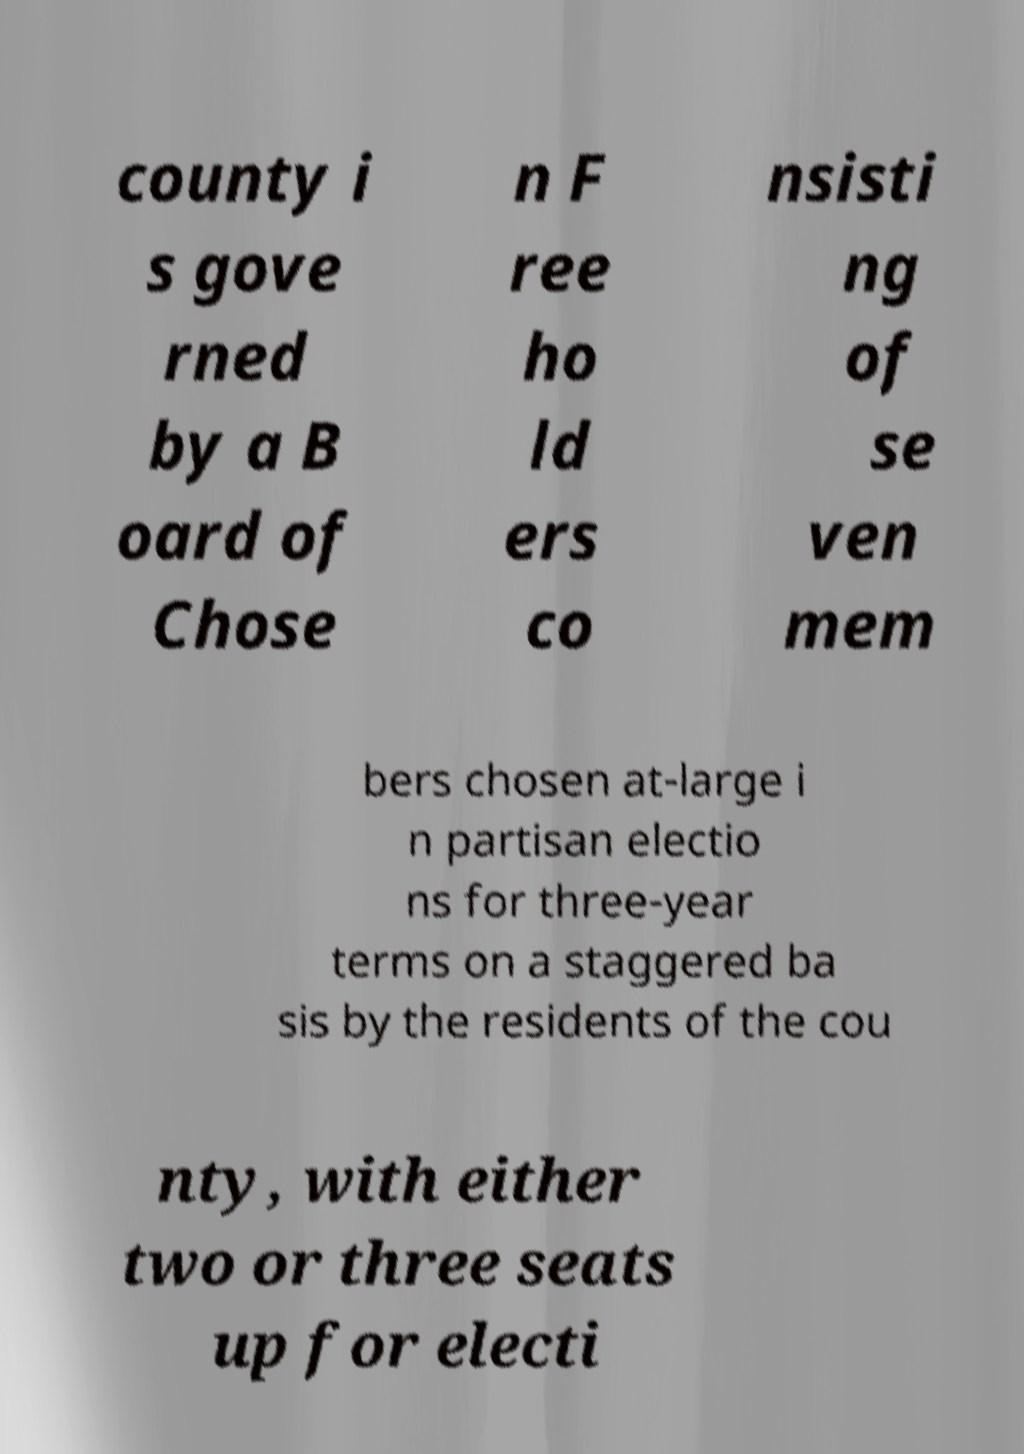Please read and relay the text visible in this image. What does it say? county i s gove rned by a B oard of Chose n F ree ho ld ers co nsisti ng of se ven mem bers chosen at-large i n partisan electio ns for three-year terms on a staggered ba sis by the residents of the cou nty, with either two or three seats up for electi 